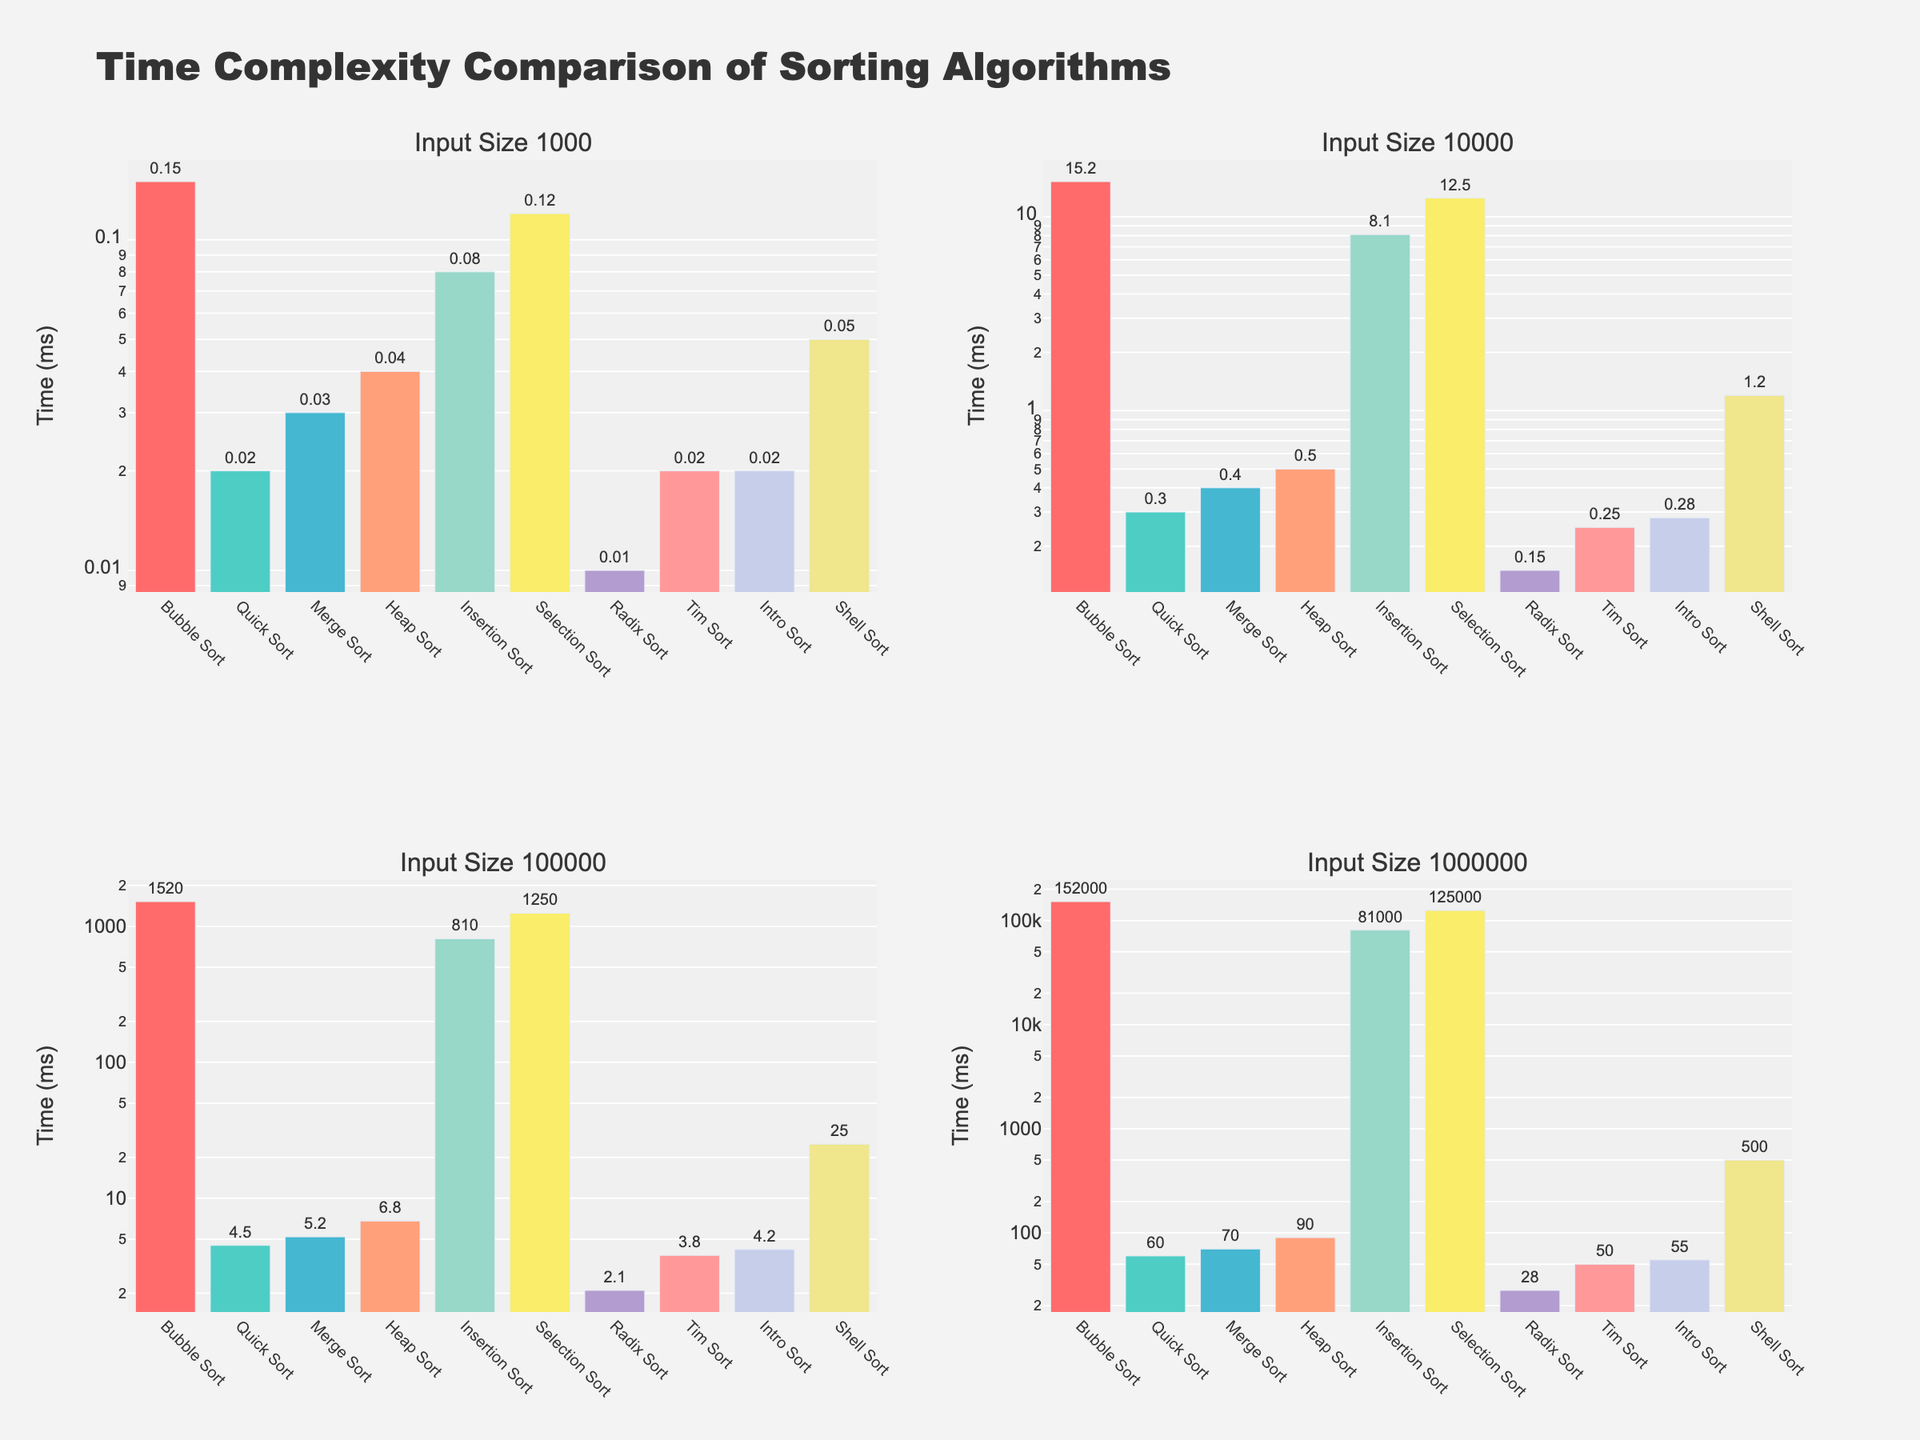Which algorithm is the slowest for an input size of 10,000? By looking at the bar heights in the subplot corresponding to 'Input Size 10000', we see that 'Bubble Sort' has the highest bar, making it the slowest algorithm for that input size.
Answer: Bubble Sort Which two algorithms have the closest time complexity for an input size of 1,000,000? Compare the bar heights in the subplot for 'Input Size 1000000'. 'Merge Sort' and 'Heap Sort' have similar bar heights, indicating their time complexities are closest.
Answer: Merge Sort and Heap Sort What's the percentage difference in time complexity between 'Quick Sort' and 'Bubble Sort' for an input size of 1,000? First, find the times for 'Quick Sort' (0.02) and 'Bubble Sort' (0.15). The percentage difference is ((0.15 - 0.02) / 0.15) * 100 ≈ 86.67%.
Answer: 86.67% Among the algorithms, which one benefits the most from increasing input size from 1,000 to 10,000? Compare the times for each algorithm between input sizes 1,000 and 10,000. 'Radix Sort' has a relatively small increase (0.01 to 0.15), indicating it benefits the most from the input size increase.
Answer: Radix Sort What is the average time complexity of 'Tim Sort' across all input sizes? Sum the times for 'Tim Sort' (0.02 + 0.25 + 3.8 + 50 = 54.07). The average is 54.07 / 4 ≈ 13.5175.
Answer: 13.5175 Which algorithm has the biggest improvement in time complexity from input size 100,000 to 1,000,000? Calculate the time decrease for each algorithm. 'Bubble Sort' drops from 1520 to 152000, but 'Selection Sort' has a more significant drop from 1250 to 125000. However, in terms of relative improvement, 'Radix Sort' improves from 2.1 to 28.
Answer: Radix Sort What's the difference in time complexity between 'Bubble Sort' and 'Intro Sort' for an input size of 100,000? Subtract the times for 'Intro Sort' (4.2) from 'Bubble Sort' (1520). The difference is 1520 - 4.2 = 1515.8.
Answer: 1515.8 